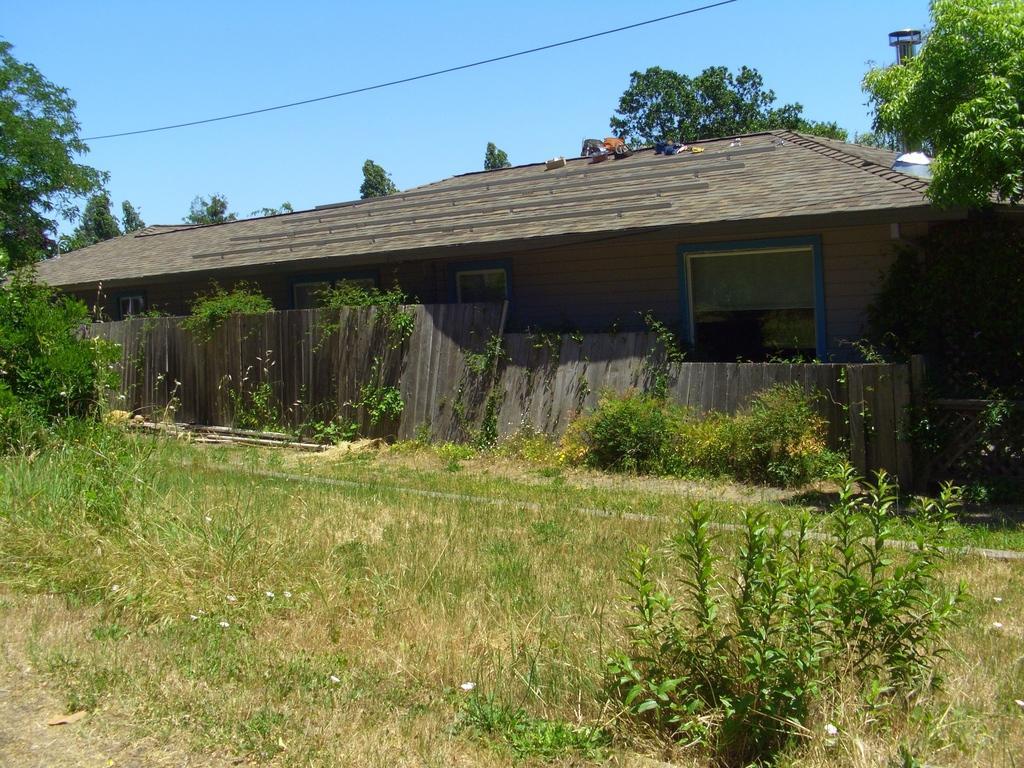Describe this image in one or two sentences. In the center of the image there is a shed. At the bottom there is grass and we can see plants. In the background there are trees and sky. There is a wire and we can see a fence. 